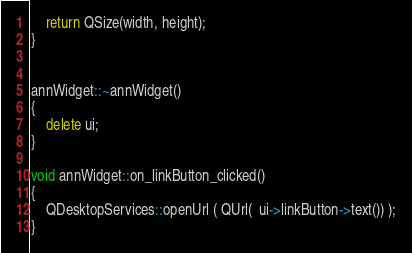<code> <loc_0><loc_0><loc_500><loc_500><_C++_>    return QSize(width, height);
}


annWidget::~annWidget()
{
    delete ui;
}

void annWidget::on_linkButton_clicked()
{
    QDesktopServices::openUrl ( QUrl(  ui->linkButton->text()) );
}
</code> 